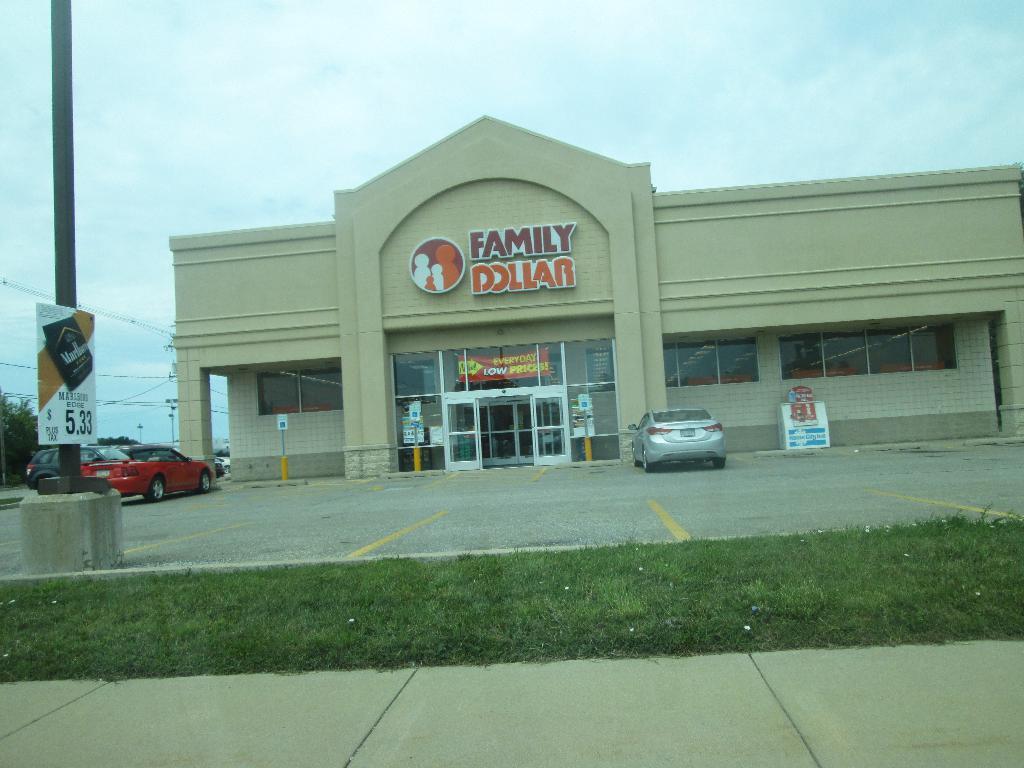Could you give a brief overview of what you see in this image? In this image, we can see a building with some doors and windows. We can also see vehicles. We can see the ground. There are a few poles. We can also see a board on the right. We can see some grass, wires. We can also see the sky. 